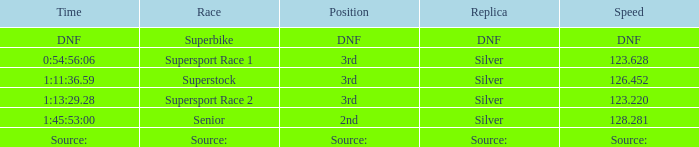Write the full table. {'header': ['Time', 'Race', 'Position', 'Replica', 'Speed'], 'rows': [['DNF', 'Superbike', 'DNF', 'DNF', 'DNF'], ['0:54:56:06', 'Supersport Race 1', '3rd', 'Silver', '123.628'], ['1:11:36.59', 'Superstock', '3rd', 'Silver', '126.452'], ['1:13:29.28', 'Supersport Race 2', '3rd', 'Silver', '123.220'], ['1:45:53:00', 'Senior', '2nd', 'Silver', '128.281'], ['Source:', 'Source:', 'Source:', 'Source:', 'Source:']]} Which race has a position of 3rd and a speed of 126.452? Superstock. 